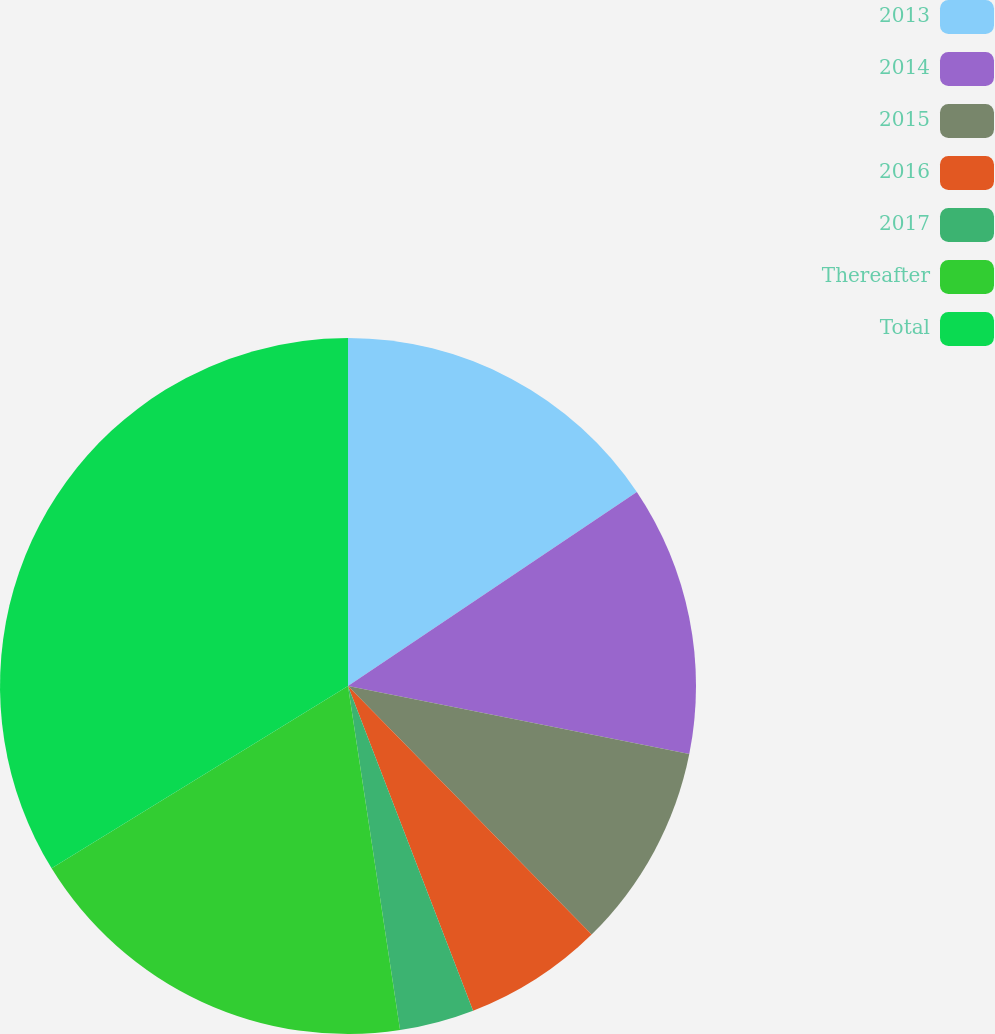<chart> <loc_0><loc_0><loc_500><loc_500><pie_chart><fcel>2013<fcel>2014<fcel>2015<fcel>2016<fcel>2017<fcel>Thereafter<fcel>Total<nl><fcel>15.58%<fcel>12.55%<fcel>9.52%<fcel>6.49%<fcel>3.46%<fcel>18.61%<fcel>33.77%<nl></chart> 